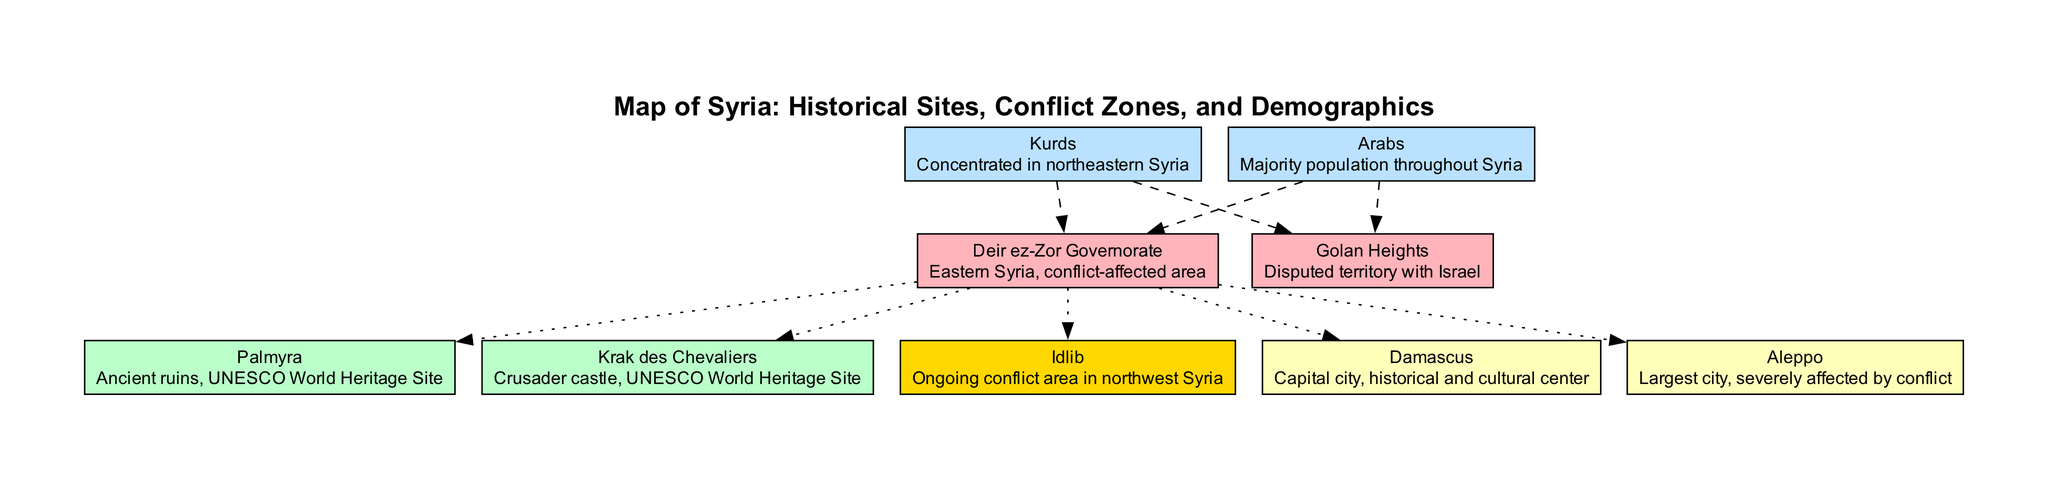What is the largest city in Syria? In the diagram, the city labeled "Aleppo" is described as the largest city in Syria. This is stated directly in the description of the city node.
Answer: Aleppo Which historical site is a UNESCO World Heritage Site known for ancient ruins? The historical site labeled "Palmyra" is specifically described as an ancient ruins site and also noted as a UNESCO World Heritage Site.
Answer: Palmyra How many conflict zones are indicated on the map? The diagram explicitly shows one conflict zone labeled "Idlib." Therefore, the count of conflict zones given in this diagram is one.
Answer: 1 What demographic group is concentrated in northeastern Syria? The demographic labeled "Kurds" is specifically stated to be concentrated in northeastern Syria within the demographics section of the diagram.
Answer: Kurds Which region is noted as a disputed territory with Israel? The diagram indicates that the "Golan Heights" is a region described as disputed territory with Israel, making it clear from the nodal description.
Answer: Golan Heights What is the relationship between the city of Damascus and historical sites? The diagram connects the city "Damascus" with historical sites described through dotted edges, indicating that there is a relationship but it does not specify what it is. The connection implies a notable significance but does not elaborate further.
Answer: Dotted connections What type of structure is "Krak des Chevaliers"? The historical site labeled "Krak des Chevaliers" is described as a Crusader castle. This specific description classifies it accordingly.
Answer: Crusader castle Which demographic is identified as the majority population throughout Syria? The population labeled "Arabs" is specifically characterized as the majority demographic in Syria, as stated in the demographic description of the diagram.
Answer: Arabs How are the regions related to the demographics displayed in the diagram? Each demographic has dashed lines connecting it to the regions, which suggest that these demographic groups have a significant presence within those regions. The dashed lines illustrate the demographic influence in the indicated areas.
Answer: Dashed connections 